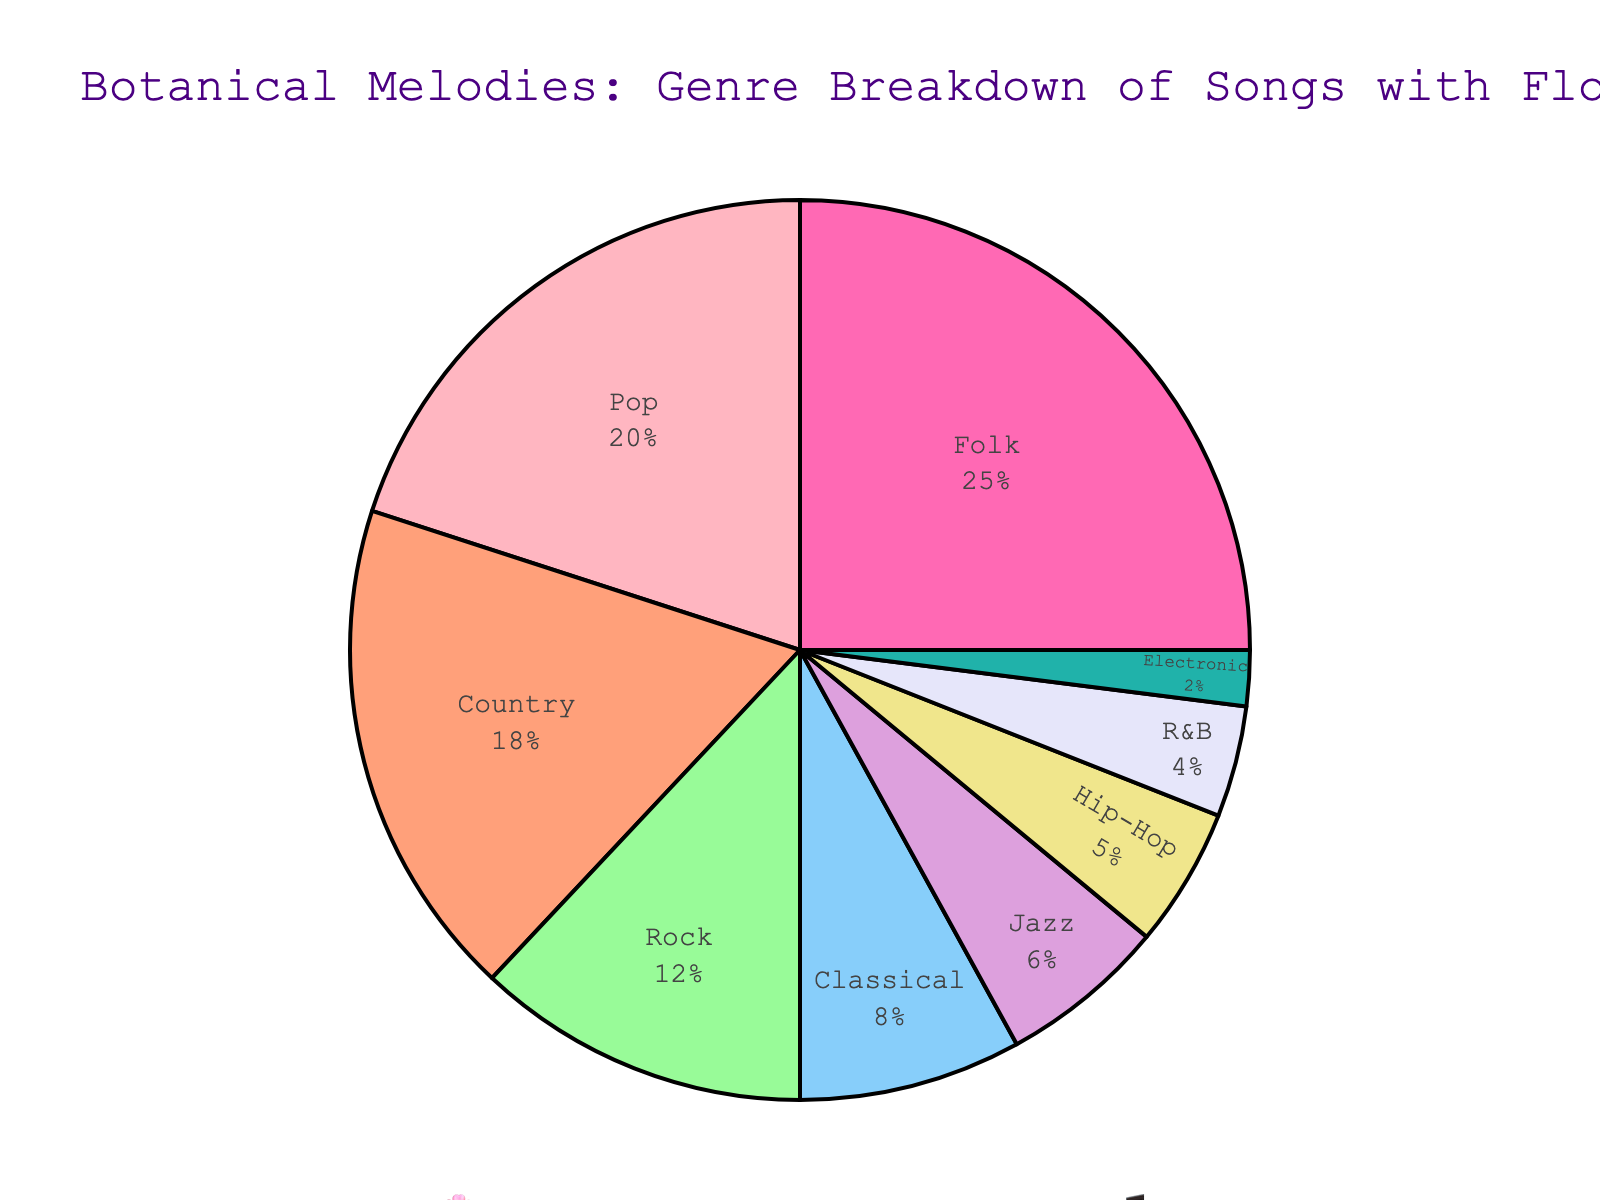What genre has the highest percentage of songs with botanical references? The largest segment in the pie chart represents the highest percentage. The label inside this segment indicates that Folk has the highest percentage.
Answer: Folk What is the combined percentage of songs with botanical references in Pop and Country genres? Identify and sum the percentages of Pop and Country. Pop is 20% and Country is 18%. Therefore, the total is 20% + 18% = 38%.
Answer: 38% How does the percentage of Rock compare to that of Jazz? According to the pie chart, the percentage of Rock is 12%, while Jazz is 6%. Since 12% > 6%, Rock has a higher percentage than Jazz.
Answer: Rock > Jazz Which genre with botanical references takes up the smallest portion of the pie chart? The smallest segment in the pie chart represents the genre with the lowest percentage. Electronic, at 2%, is the smallest.
Answer: Electronic What is the difference in percentages between R&B and Classical genres? From the pie chart, R&B is 4% and Classical is 8%. The difference is 8% - 4% = 4%.
Answer: 4% What genre has a percentage of songs that is exactly twice that of Jazz? Jazz has 6%, so look for a genre that has 6% * 2 = 12%. The pie chart shows that Rock fits this condition with 12%.
Answer: Rock Among Hip-Hop, Jazz, and R&B, which genre has the highest percentage? Review the percentages: Hip-Hop has 5%, Jazz has 6%, and R&B has 4%. Jazz has the highest percentage among these three genres.
Answer: Jazz What combined percentage do Classical, Jazz, and Hip-Hop songs with botanical references share? Sum the individual percentages: Classical (8%) + Jazz (6%) + Hip-Hop (5%) = 8% + 6% + 5% = 19%.
Answer: 19% Which genre has a percentage that is the arithmetic mean of the percentages of Country and R&B? Calculate the arithmetic mean: (18% for Country + 4% for R&B) / 2 = 22% / 2 = 11%. Find the genre with this percentage, which doesn’t exist.
Answer: None 